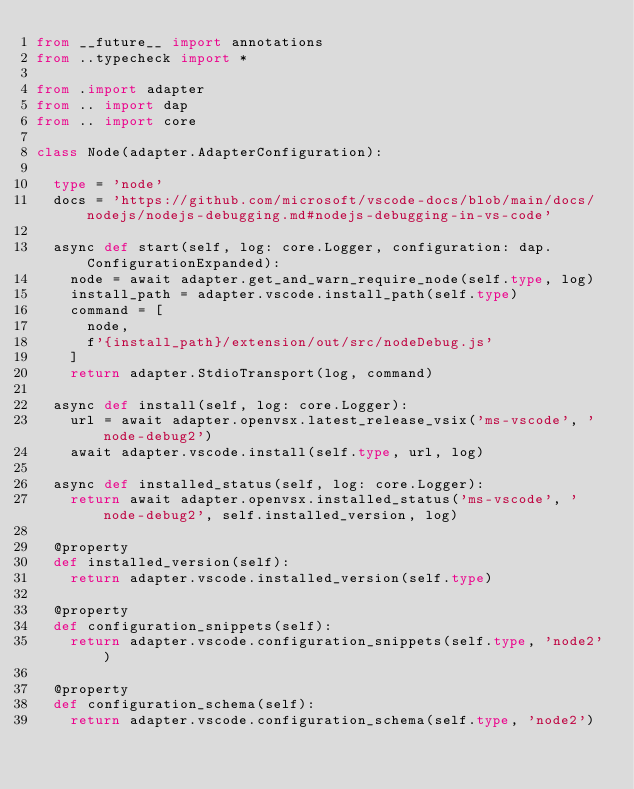Convert code to text. <code><loc_0><loc_0><loc_500><loc_500><_Python_>from __future__ import annotations
from ..typecheck import *

from .import adapter
from .. import dap
from .. import core

class Node(adapter.AdapterConfiguration):

	type = 'node'
	docs = 'https://github.com/microsoft/vscode-docs/blob/main/docs/nodejs/nodejs-debugging.md#nodejs-debugging-in-vs-code'

	async def start(self, log: core.Logger, configuration: dap.ConfigurationExpanded):
		node = await adapter.get_and_warn_require_node(self.type, log)
		install_path = adapter.vscode.install_path(self.type)
		command = [
			node,
			f'{install_path}/extension/out/src/nodeDebug.js'
		]
		return adapter.StdioTransport(log, command)

	async def install(self, log: core.Logger):
		url = await adapter.openvsx.latest_release_vsix('ms-vscode', 'node-debug2')
		await adapter.vscode.install(self.type, url, log)

	async def installed_status(self, log: core.Logger):
		return await adapter.openvsx.installed_status('ms-vscode', 'node-debug2', self.installed_version, log)

	@property
	def installed_version(self):
		return adapter.vscode.installed_version(self.type)

	@property
	def configuration_snippets(self):
		return adapter.vscode.configuration_snippets(self.type, 'node2')

	@property
	def configuration_schema(self):
		return adapter.vscode.configuration_schema(self.type, 'node2')
</code> 